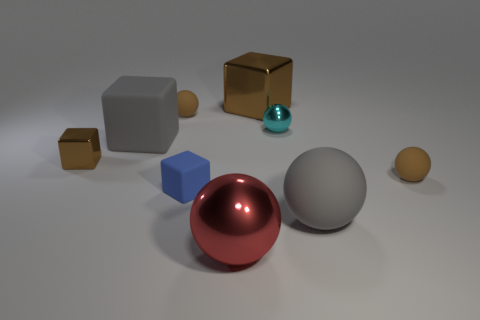Are there more big blocks than big gray rubber blocks?
Your answer should be very brief. Yes. There is a large thing that is behind the cyan object; is its shape the same as the blue object?
Keep it short and to the point. Yes. Is the number of large brown objects less than the number of small cylinders?
Offer a very short reply. No. There is a blue object that is the same size as the cyan object; what is its material?
Offer a very short reply. Rubber. Is the color of the big matte cube the same as the big matte sphere that is on the right side of the cyan metal object?
Make the answer very short. Yes. Is the number of big red shiny objects that are behind the large gray rubber block less than the number of rubber objects?
Your answer should be very brief. Yes. How many matte blocks are there?
Provide a succinct answer. 2. What shape is the big gray thing to the left of the brown ball left of the small cyan metallic object?
Offer a very short reply. Cube. There is a tiny metallic sphere; what number of small cyan spheres are to the left of it?
Your answer should be very brief. 0. Is the cyan thing made of the same material as the gray object that is left of the red metallic sphere?
Make the answer very short. No. 